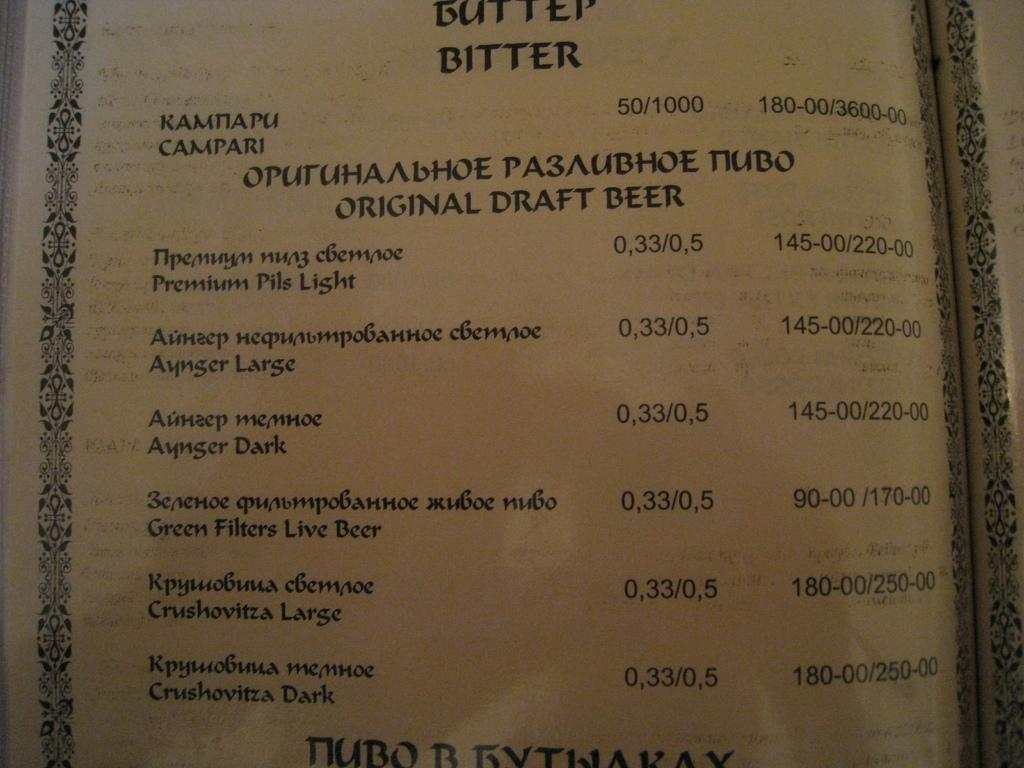<image>
Write a terse but informative summary of the picture. Catalog showing a list of different original draft beers. 